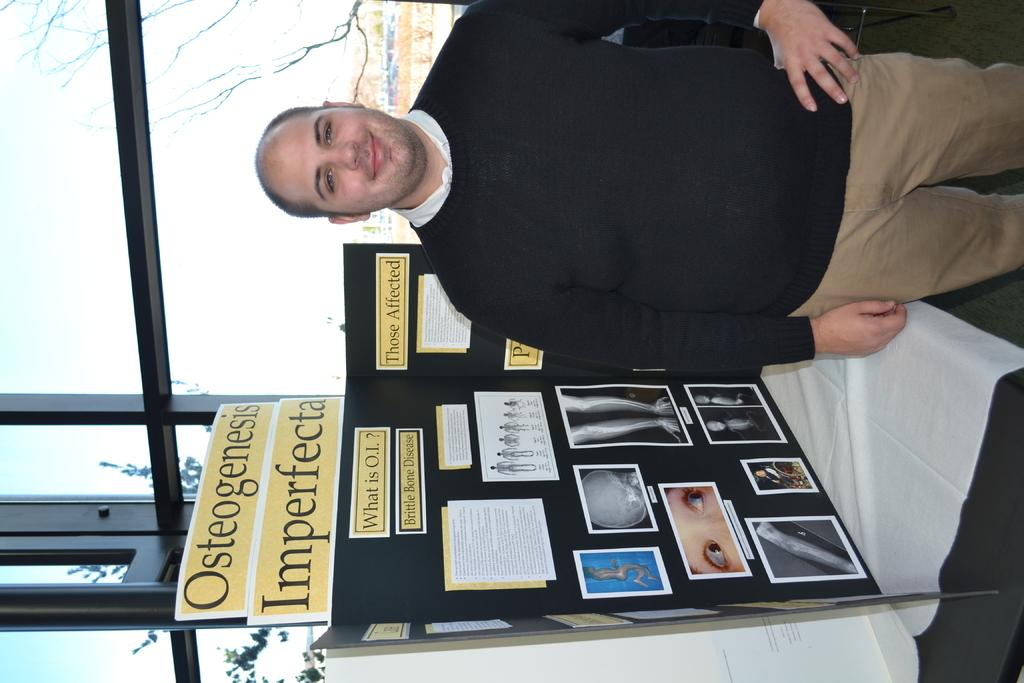Provide a one-sentence caption for the provided image. a man in a black sweater standing in front of a osteogenesis imperfecta project board. 